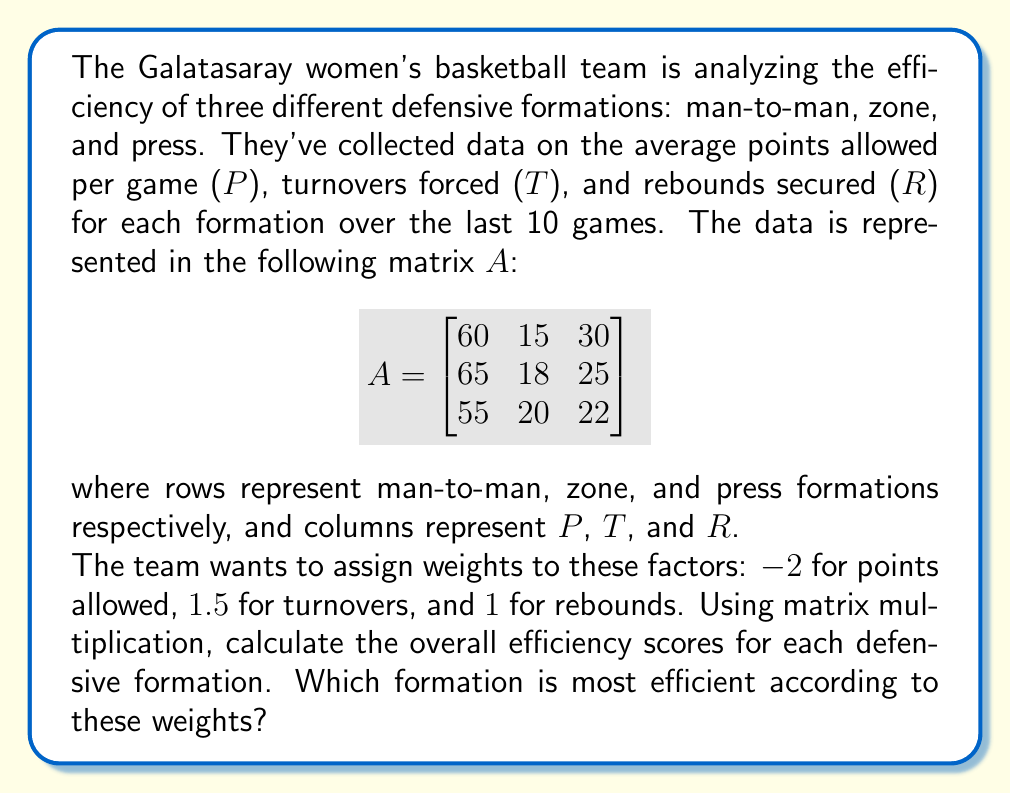Teach me how to tackle this problem. Let's approach this step-by-step:

1) First, we need to create a weight vector w:
   $$w = \begin{bmatrix} -2 \\ 1.5 \\ 1 \end{bmatrix}$$

2) To find the efficiency scores, we need to multiply matrix A by vector w:
   $$\text{Efficiency} = A \cdot w$$

3) Let's perform the matrix multiplication:
   $$\begin{bmatrix}
   60 & 15 & 30 \\
   65 & 18 & 25 \\
   55 & 20 & 22
   \end{bmatrix} \cdot 
   \begin{bmatrix} -2 \\ 1.5 \\ 1 \end{bmatrix}$$

4) Calculating each row:
   Man-to-man: $60(-2) + 15(1.5) + 30(1) = -120 + 22.5 + 30 = -67.5$
   Zone: $65(-2) + 18(1.5) + 25(1) = -130 + 27 + 25 = -78$
   Press: $55(-2) + 20(1.5) + 22(1) = -110 + 30 + 22 = -58$

5) The result is:
   $$\text{Efficiency} = \begin{bmatrix} -67.5 \\ -78 \\ -58 \end{bmatrix}$$

6) The highest (least negative) score indicates the most efficient formation. In this case, it's the press defense with a score of -58.
Answer: Press defense (-58) 